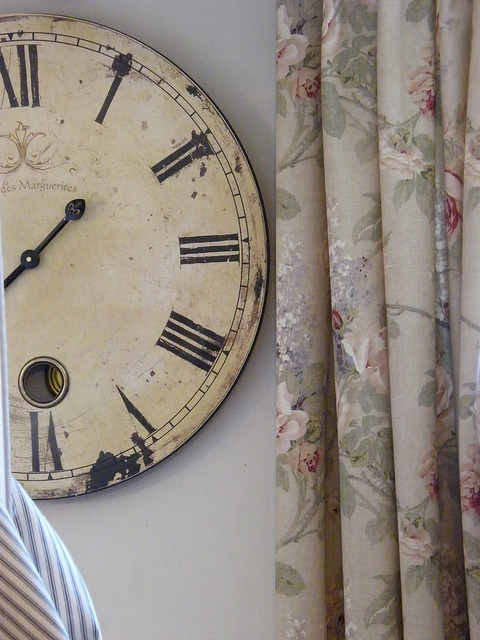Describe the objects in this image and their specific colors. I can see a clock in gray, tan, and black tones in this image. 